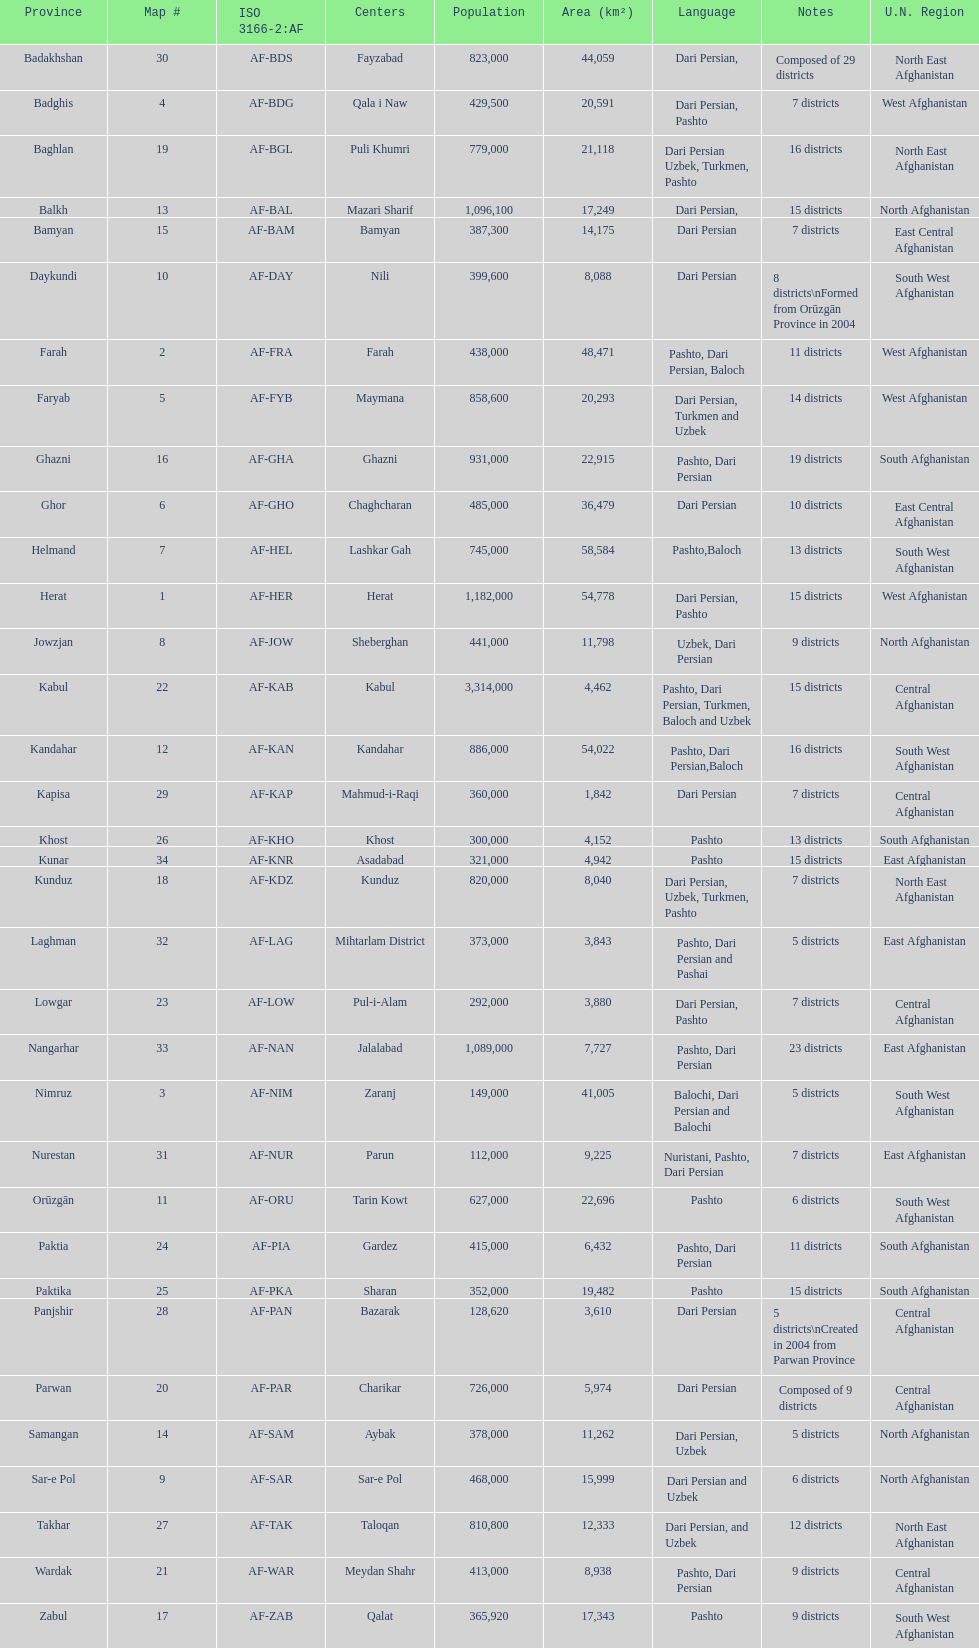In how many regions in afghanistan do they speak dari persian? 28. 